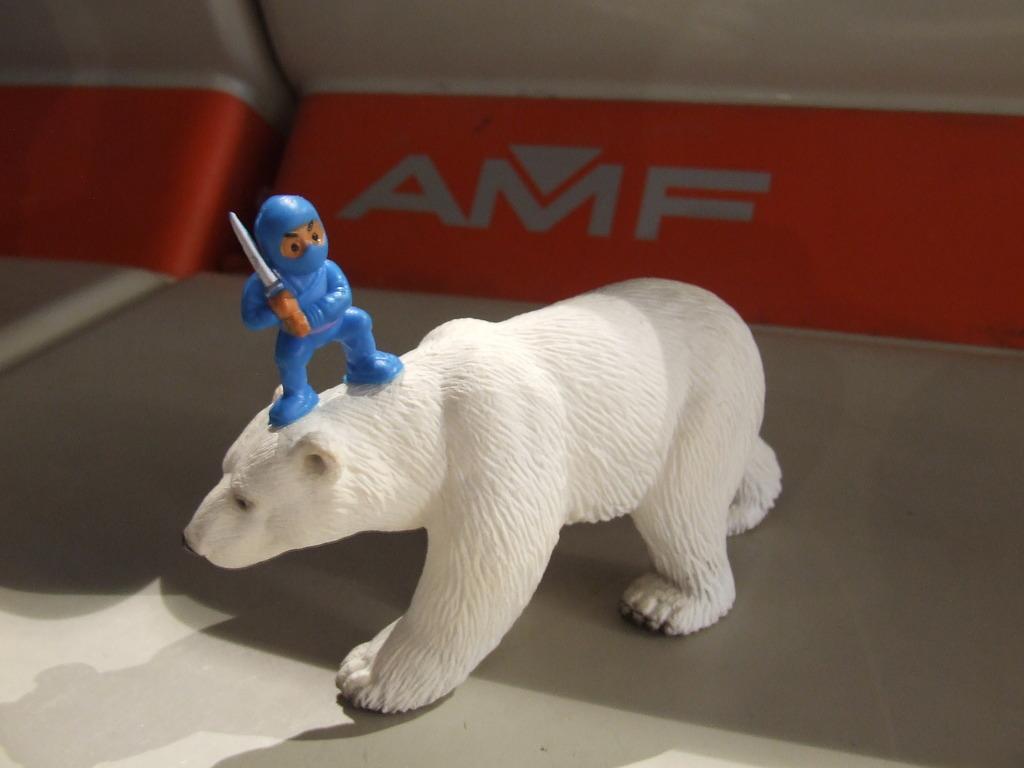Please provide a concise description of this image. In this image we can see a statue of a polar bear. On the polar bear there is a statue of a person holding something in the hand. In the background something is written on a red surface. 